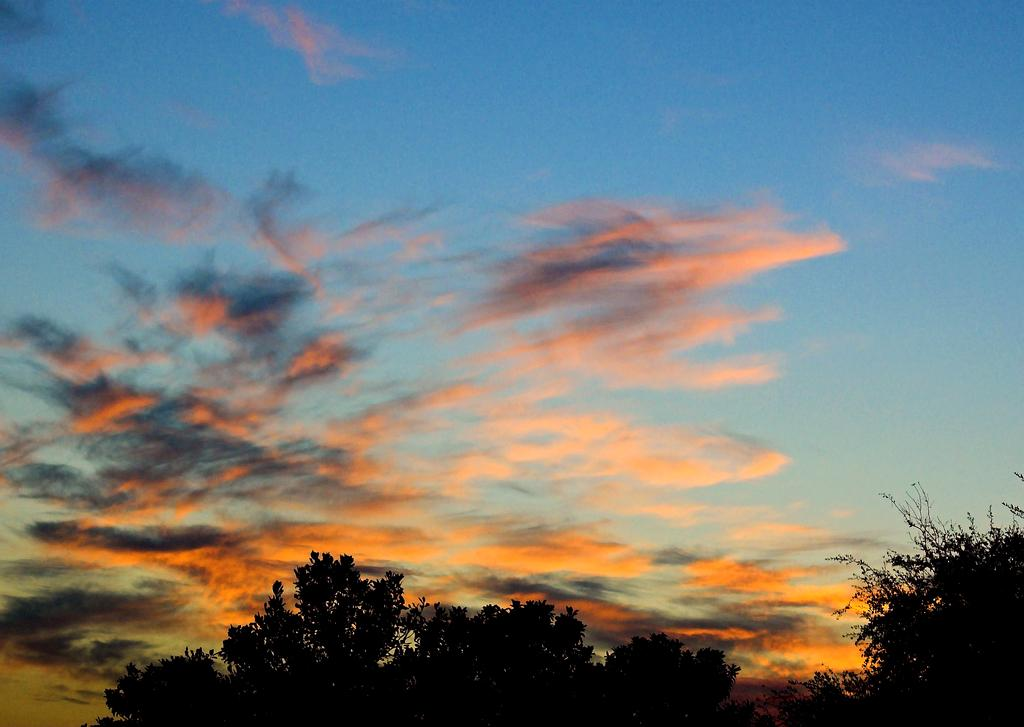What is the condition of the sky in the image? The sky in the image is cloudy. What type of vegetation can be seen at the bottom of the image? There are trees visible at the bottom of the image. What type of muscle is being exercised by the trees in the image? There are no muscles present in the image, as it features a cloudy sky and trees. What is the interest rate for the trees in the image? There is no reference to interest rates or financial matters in the image, as it features a cloudy sky and trees. 